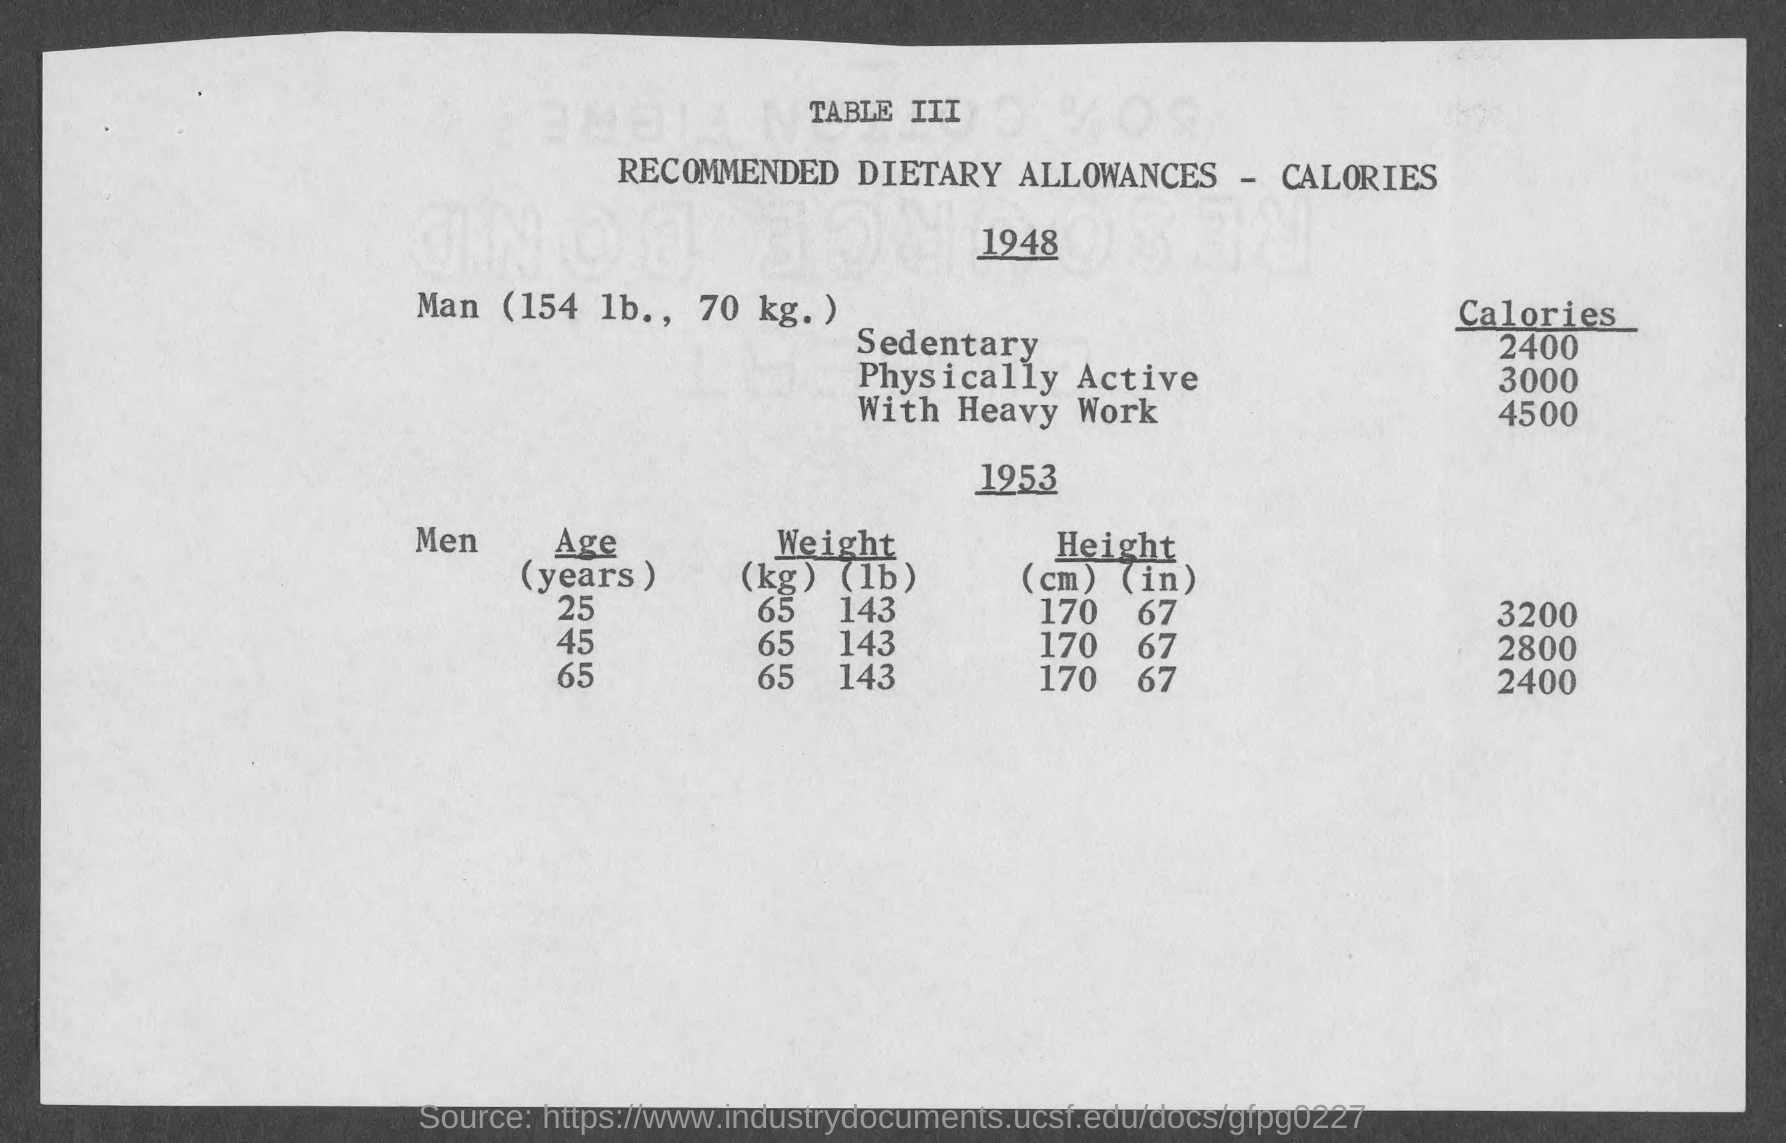What is the title of table iii?
Offer a very short reply. Recommended Dietary Allowances - Calories. What is the recommend calorie intake for sedentary ?
Offer a very short reply. 2400 cal. What is the recommend calorie intake for physically active man  ?
Your response must be concise. 3000. What is the recommend calorie intake for man  with heavy work?
Your answer should be compact. 4500. What must be weight of men at 25 years in kg?
Provide a short and direct response. 65. 